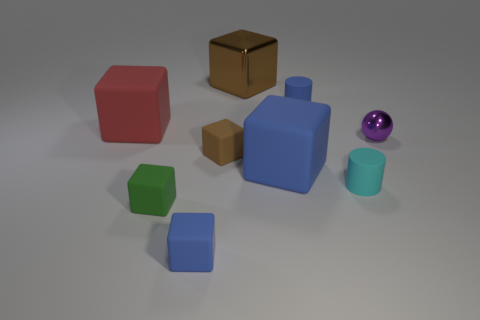Subtract all green blocks. How many blocks are left? 5 Subtract all green blocks. How many blocks are left? 5 Subtract all purple spheres. How many brown cubes are left? 2 Subtract all blocks. How many objects are left? 3 Subtract all brown blocks. Subtract all yellow balls. How many blocks are left? 4 Add 5 green metallic spheres. How many green metallic spheres exist? 5 Subtract 0 yellow cylinders. How many objects are left? 9 Subtract all large purple rubber objects. Subtract all small blue blocks. How many objects are left? 8 Add 7 brown metal blocks. How many brown metal blocks are left? 8 